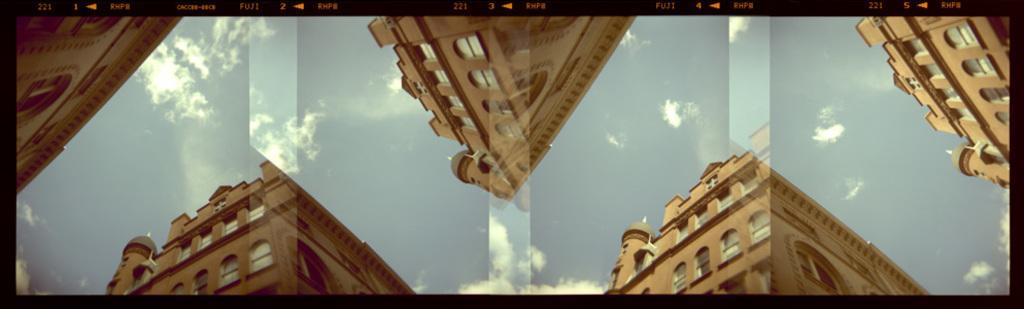Describe this image in one or two sentences. This looks like an edited image. These are the buildings with windows. These are the clouds in the sky. 